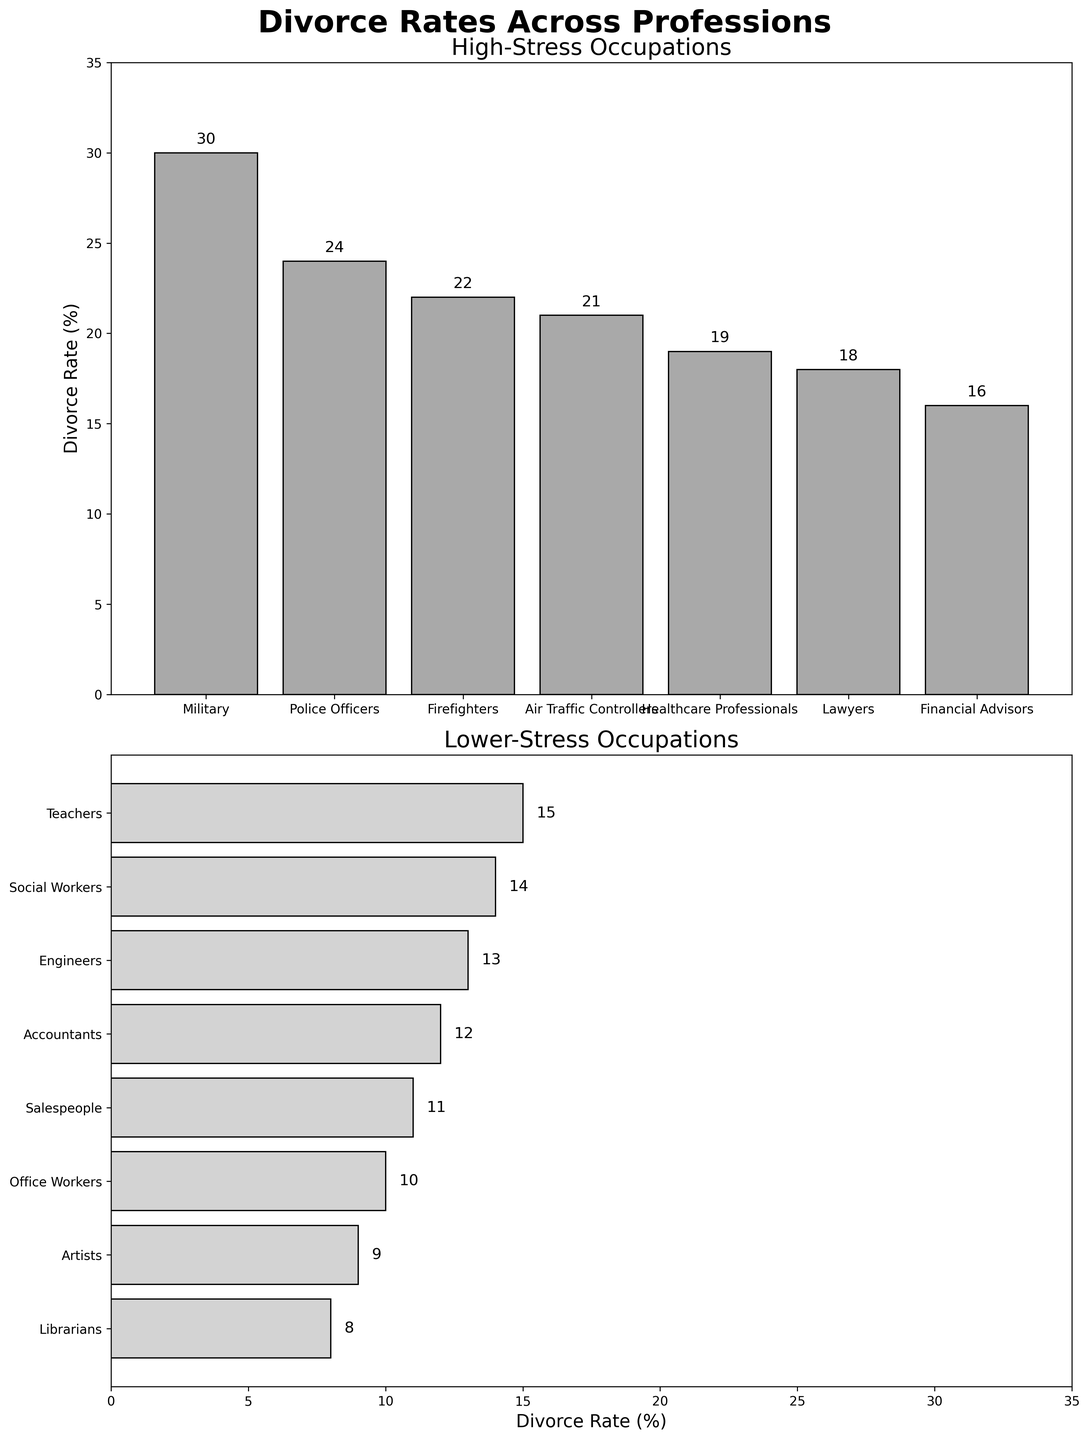What is the title of the entire figure? The title of the figure is displayed at the top and reads 'Divorce Rates Across Professions'.
Answer: Divorce Rates Across Professions What profession has the highest divorce rate in the high-stress occupations bar chart? By looking at the first bar chart titled 'High-Stress Occupations', the bar corresponding to 'Military' has the highest value at 30%.
Answer: Military Which profession has the lowest divorce rate among the high-stress occupations? In the 'High-Stress Occupations' bar chart, the 'Healthcare Professionals' bar has the lowest value at 19%.
Answer: Healthcare Professionals Calculate the average divorce rate of the top 3 professions in the high-stress occupations. The top 3 professions in the high-stress occupations are Military (30), Police Officers (24), and Firefighters (22). The average divorce rate is calculated as (30 + 24 + 22) / 3.
Answer: 25.33 What is the highest divorce rate among the lower-stress occupations? In the bar chart titled 'Lower-Stress Occupations', 'Teachers' have the highest value at 15%.
Answer: Teachers Compare the divorce rates of 'Engineers' and 'Lawyers'. Which profession has a higher rate? 'Lawyers' appear in the high-stress occupations bar chart with a rate of 18%. 'Engineers' are in the lower-stress occupations with a rate of 13%. Lawyers have a higher rate.
Answer: Lawyers Which section of the figure has bars oriented horizontally? The 'Lower-Stress Occupations' bar chart below displays bars oriented horizontally.
Answer: Lower-Stress Occupations Is there any profession with a divorce rate lower than 10%? If yes, name it. By looking at the 'Lower-Stress Occupations' bar chart, the professions 'Artists' and 'Librarians' have divorce rates of 9% and 8%, respectively, which are below 10%.
Answer: Yes, Artists and Librarians What is the difference in divorce rates between 'Salespeople' and 'Office Workers'? The divorce rate for 'Salespeople' is 11% and for 'Office Workers' is 10%. The difference is 11% - 10%.
Answer: 1% What is the total number of professions listed in both bar charts? There are 7 professions listed in the 'High-Stress Occupations' bar chart and 8 professions in the 'Lower-Stress Occupations' bar chart. Summing these up gives 7 + 8.
Answer: 15 